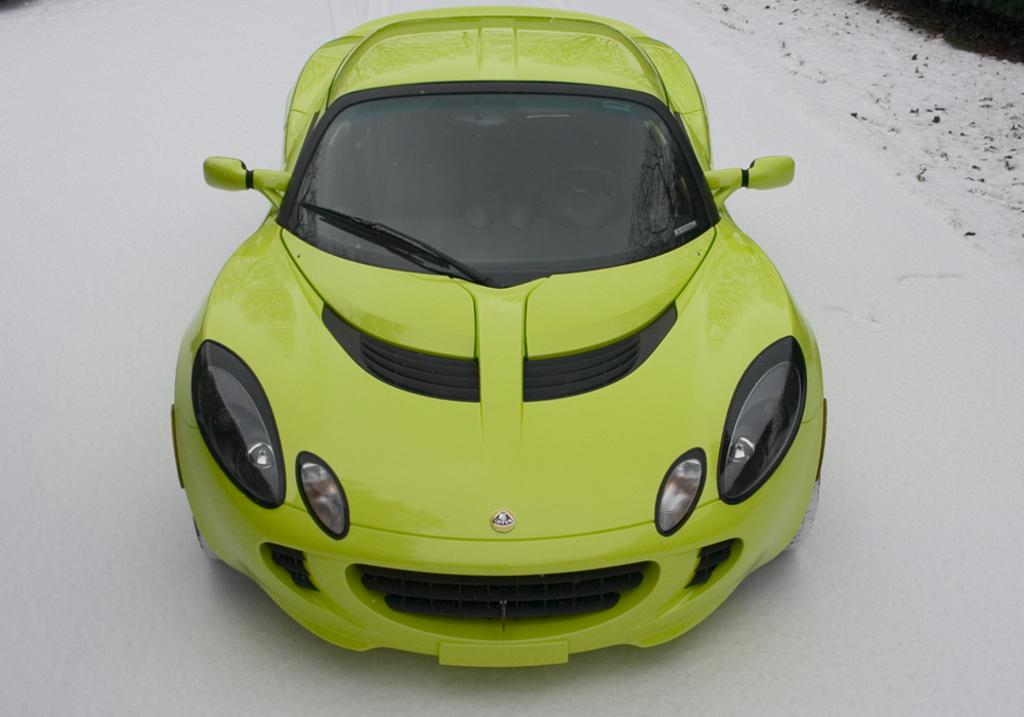What type of vehicle is in the image? There is a sports car in the image. What color is the sports car? The sports car is green in color. What is the setting or environment in which the sports car is located? The sports car is surrounded by snow. What type of approval does the sports car need to enter the hall in the image? There is no hall or approval process mentioned in the image; it only features a green sports car surrounded by snow. 